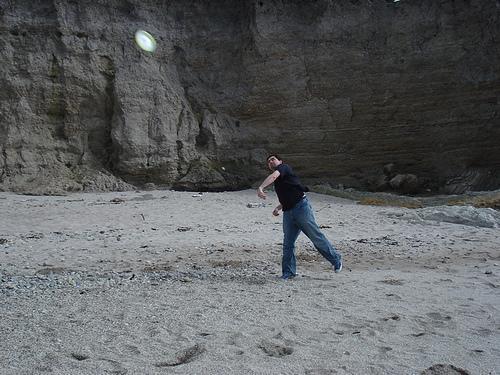How many people are shown?
Give a very brief answer. 1. How many giraffes are there?
Give a very brief answer. 0. 